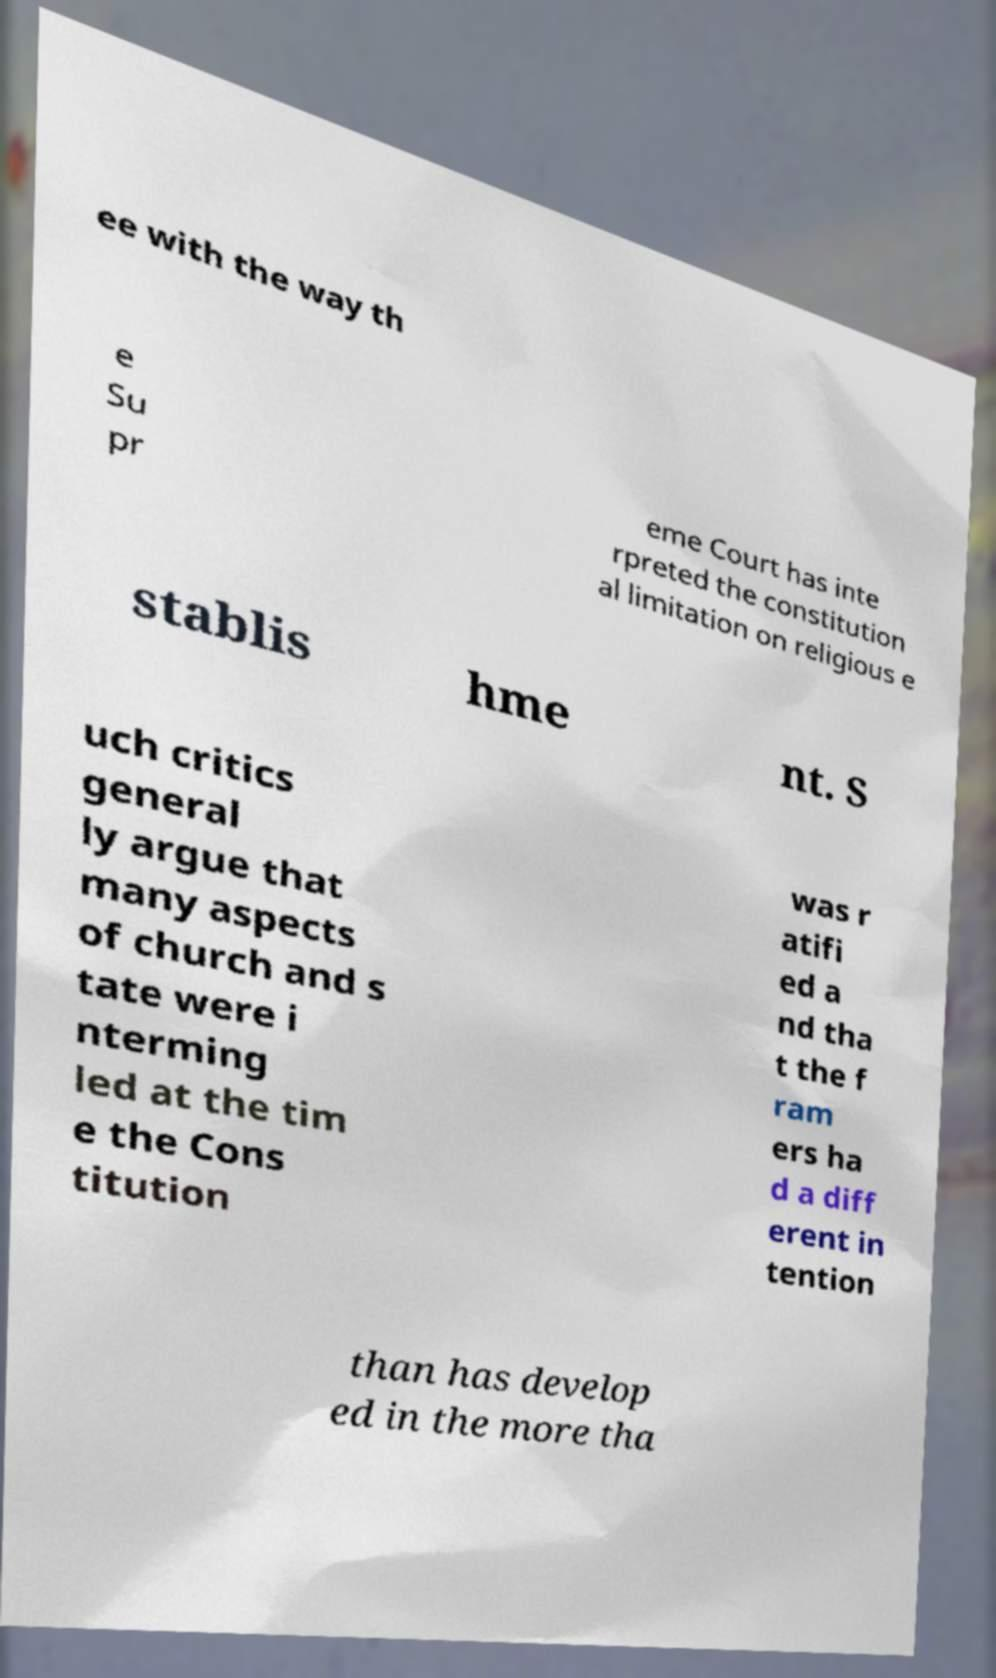What messages or text are displayed in this image? I need them in a readable, typed format. ee with the way th e Su pr eme Court has inte rpreted the constitution al limitation on religious e stablis hme nt. S uch critics general ly argue that many aspects of church and s tate were i nterming led at the tim e the Cons titution was r atifi ed a nd tha t the f ram ers ha d a diff erent in tention than has develop ed in the more tha 